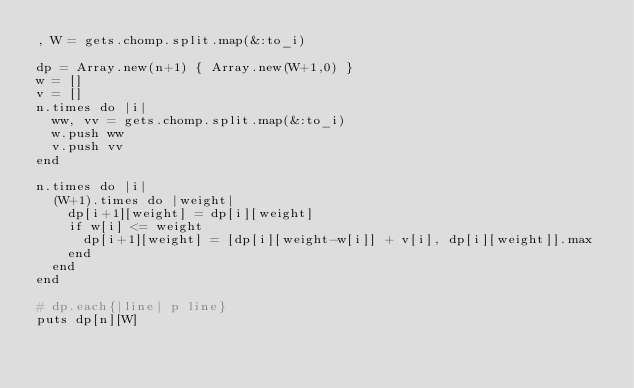Convert code to text. <code><loc_0><loc_0><loc_500><loc_500><_Ruby_>, W = gets.chomp.split.map(&:to_i)

dp = Array.new(n+1) { Array.new(W+1,0) }
w = []
v = []
n.times do |i|
  ww, vv = gets.chomp.split.map(&:to_i)
  w.push ww
  v.push vv
end

n.times do |i|
  (W+1).times do |weight|
    dp[i+1][weight] = dp[i][weight]
    if w[i] <= weight
      dp[i+1][weight] = [dp[i][weight-w[i]] + v[i], dp[i][weight]].max
    end
  end
end

# dp.each{|line| p line}
puts dp[n][W]</code> 